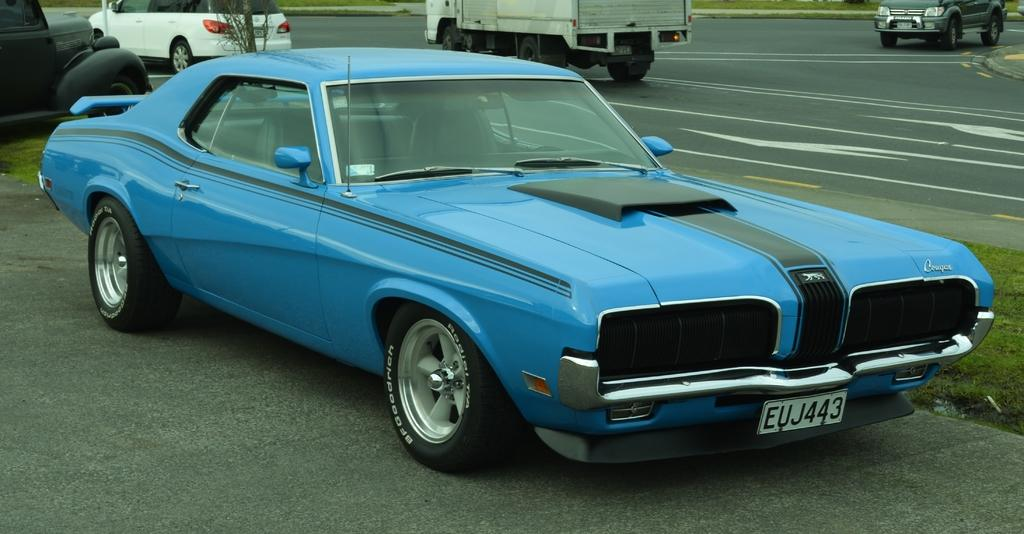What type of vehicles are on the ground in the image? There are cars on the ground in the image. What type of vegetation can be seen in the image? There is grass visible in the image. What other object can be seen in the image besides the cars and grass? There is a plant in the image. What type of vehicles are on the road in the image? There are vehicles on the road in the image. What type of meal is being prepared in the image? There is no meal preparation visible in the image. Can you see a turkey in the image? There is no turkey present in the image. 